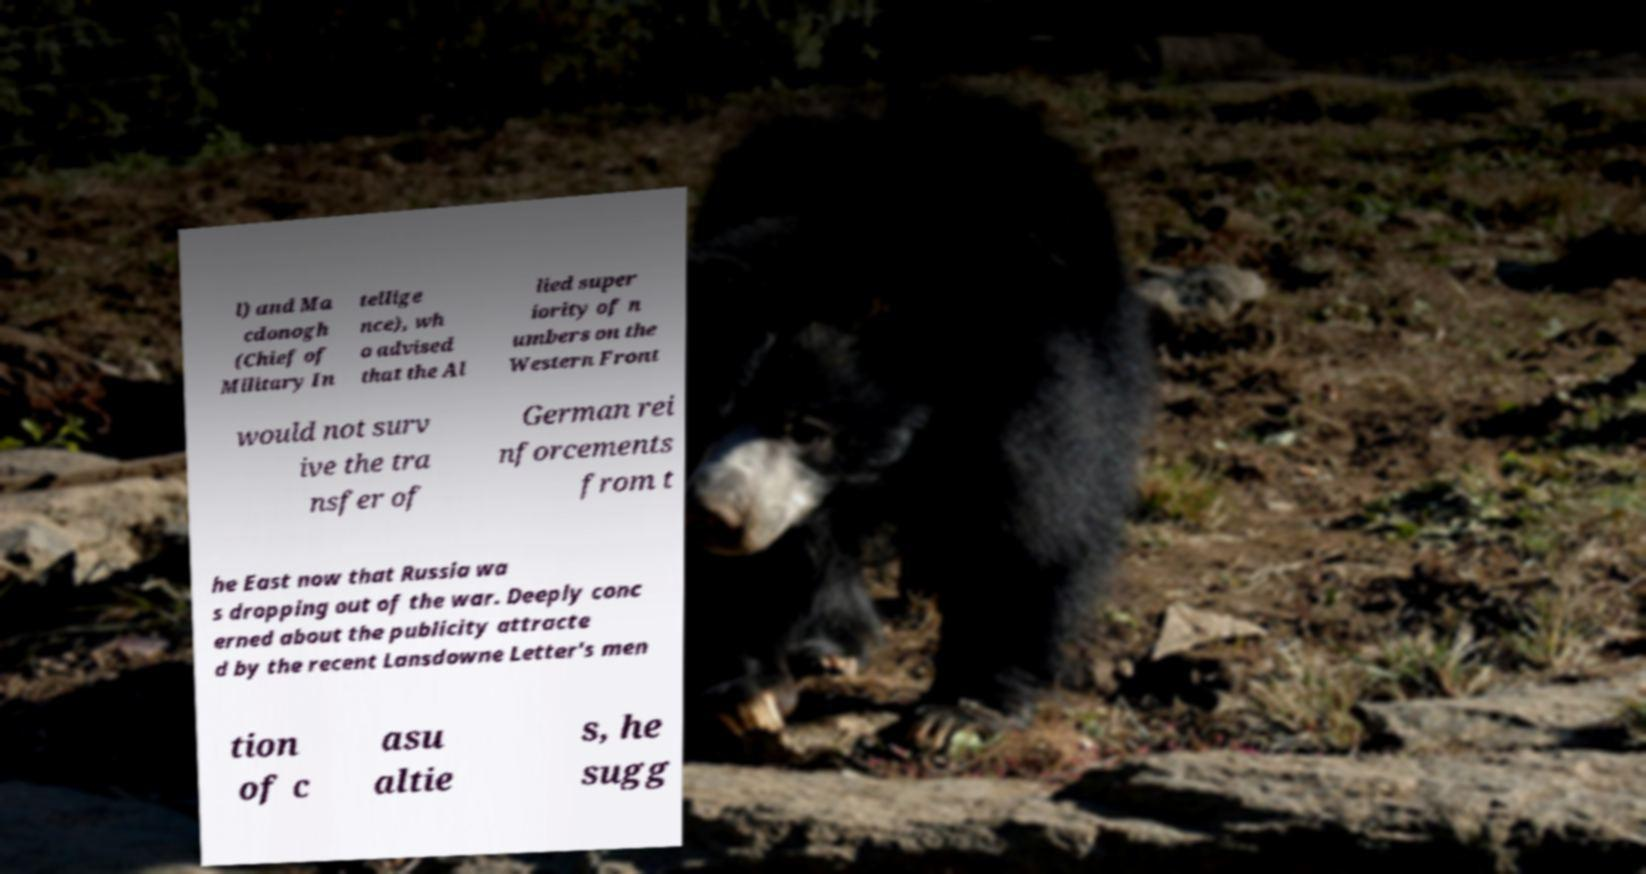Can you read and provide the text displayed in the image?This photo seems to have some interesting text. Can you extract and type it out for me? l) and Ma cdonogh (Chief of Military In tellige nce), wh o advised that the Al lied super iority of n umbers on the Western Front would not surv ive the tra nsfer of German rei nforcements from t he East now that Russia wa s dropping out of the war. Deeply conc erned about the publicity attracte d by the recent Lansdowne Letter's men tion of c asu altie s, he sugg 